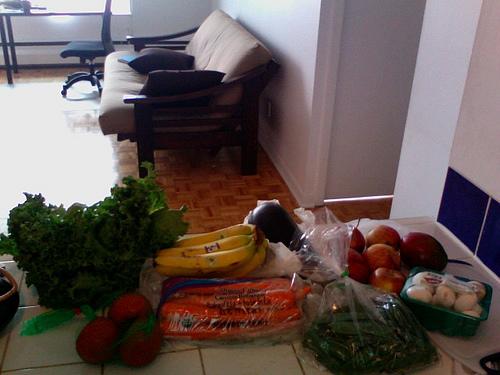How many oranges are in this picture?
Quick response, please. 0. Is the food on the counter healthy?
Keep it brief. Yes. Are there bananas on the counter?
Answer briefly. Yes. What type of wood flooring is in the room?
Concise answer only. Tile. 